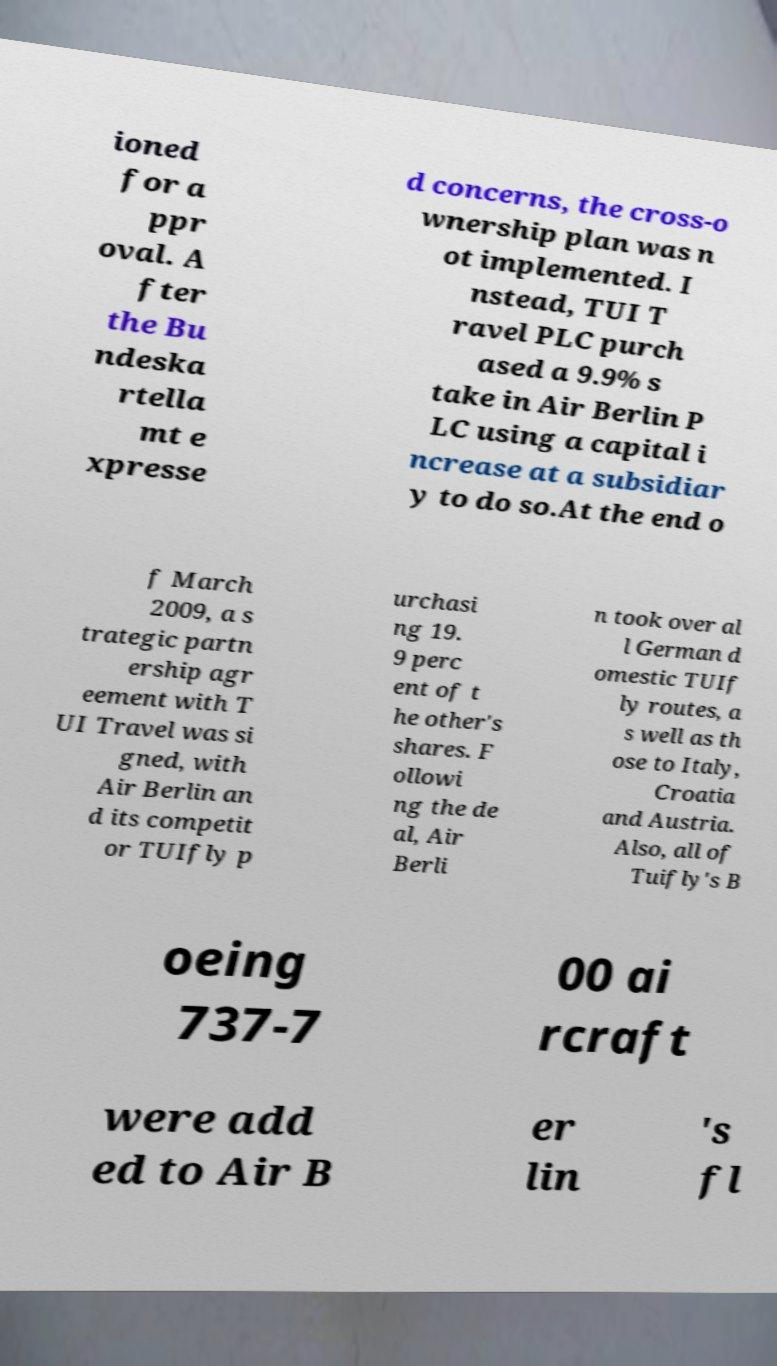Please read and relay the text visible in this image. What does it say? ioned for a ppr oval. A fter the Bu ndeska rtella mt e xpresse d concerns, the cross-o wnership plan was n ot implemented. I nstead, TUI T ravel PLC purch ased a 9.9% s take in Air Berlin P LC using a capital i ncrease at a subsidiar y to do so.At the end o f March 2009, a s trategic partn ership agr eement with T UI Travel was si gned, with Air Berlin an d its competit or TUIfly p urchasi ng 19. 9 perc ent of t he other's shares. F ollowi ng the de al, Air Berli n took over al l German d omestic TUIf ly routes, a s well as th ose to Italy, Croatia and Austria. Also, all of Tuifly's B oeing 737-7 00 ai rcraft were add ed to Air B er lin 's fl 